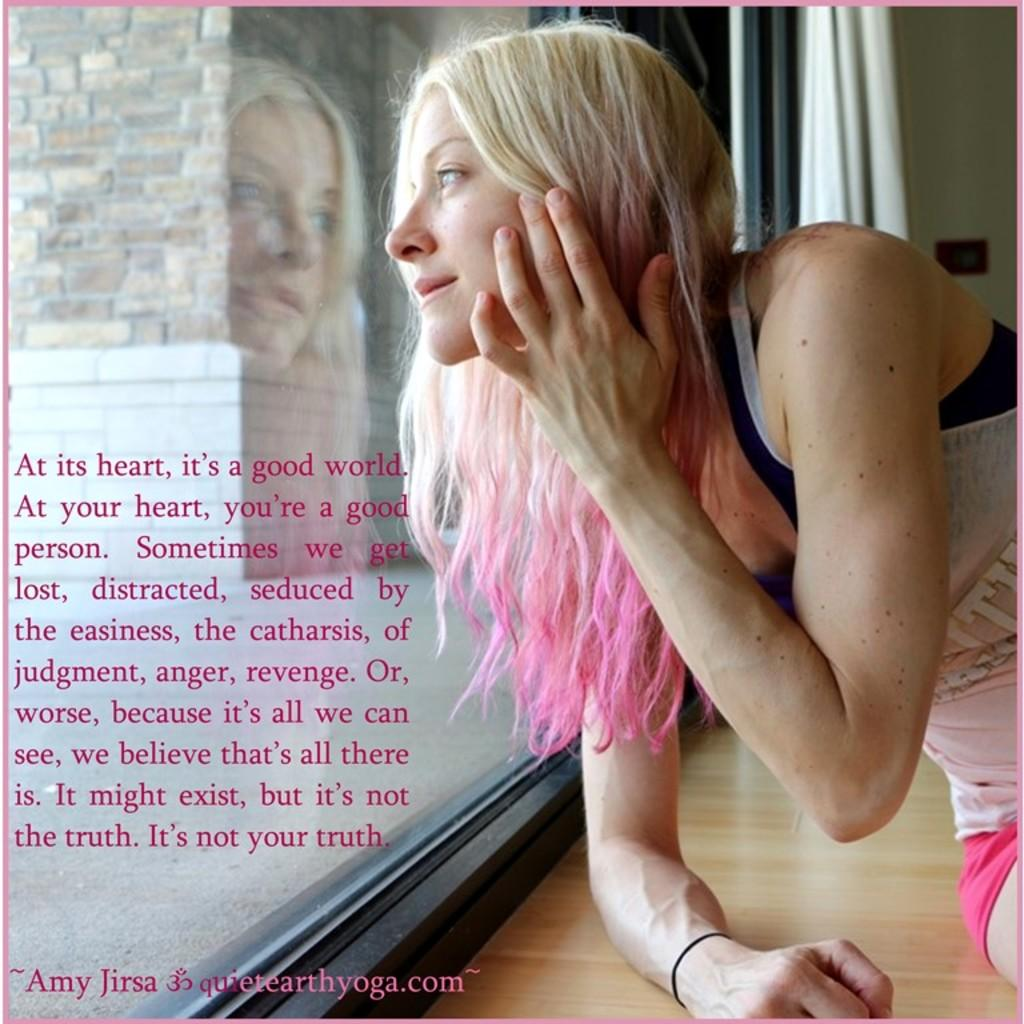Who or what is in the image? There is a person in the image. Where is the person located in relation to other elements in the image? The person is in front of a window. What can be seen on the left side of the image? There is text on the left side of the image. What type of leather material is visible on the person's clothing in the image? There is no leather material visible on the person's clothing in the image. Is there a lamp present in the image? There is no lamp present in the image. 